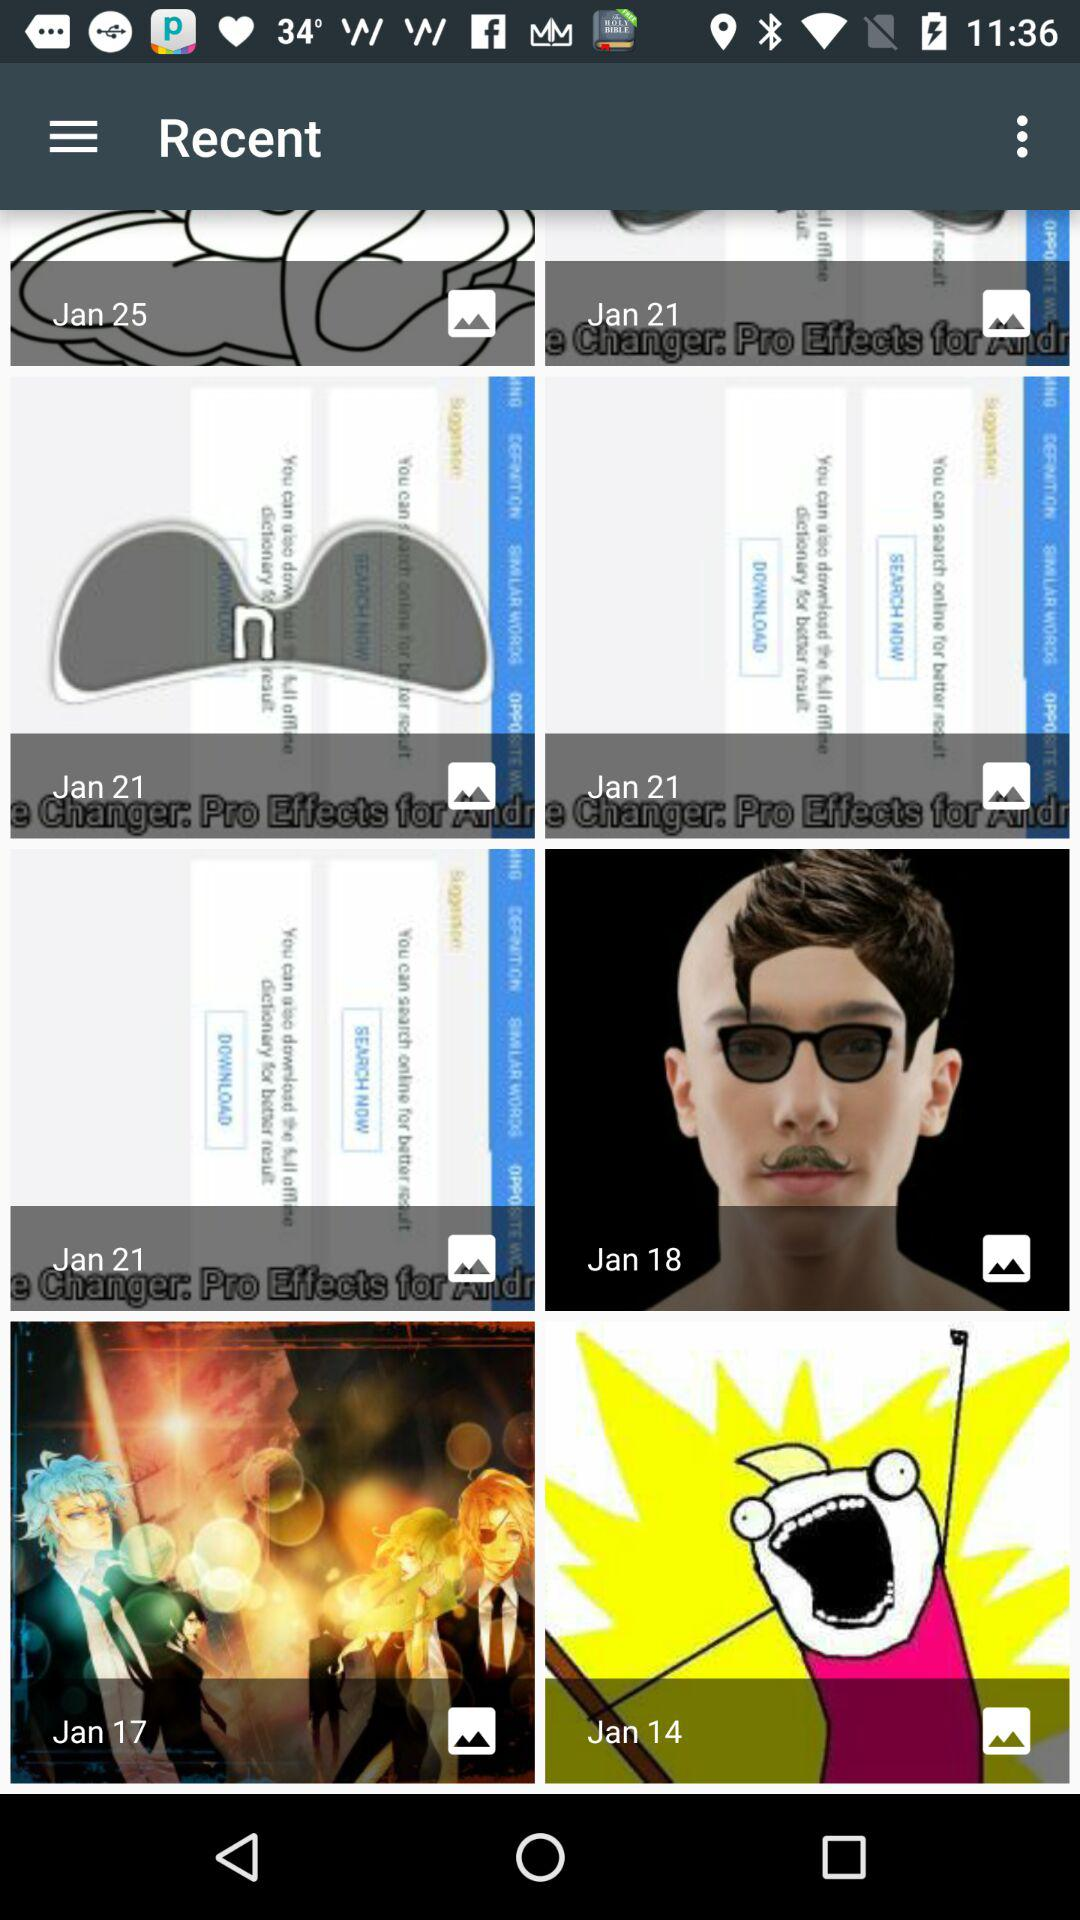When was the recent image uploaded?
When the provided information is insufficient, respond with <no answer>. <no answer> 